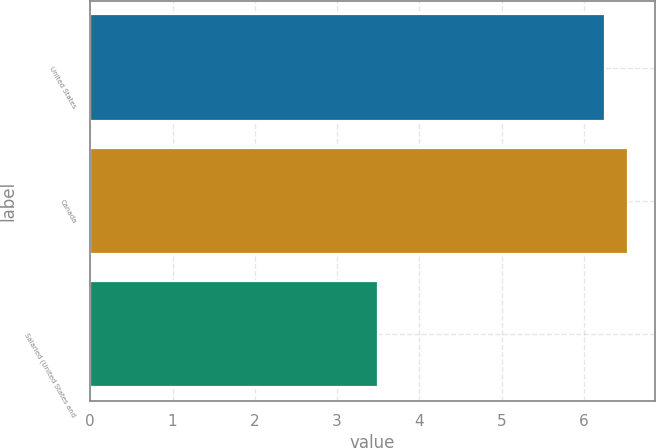Convert chart. <chart><loc_0><loc_0><loc_500><loc_500><bar_chart><fcel>United States<fcel>Canada<fcel>Salaried (United States and<nl><fcel>6.25<fcel>6.53<fcel>3.5<nl></chart> 